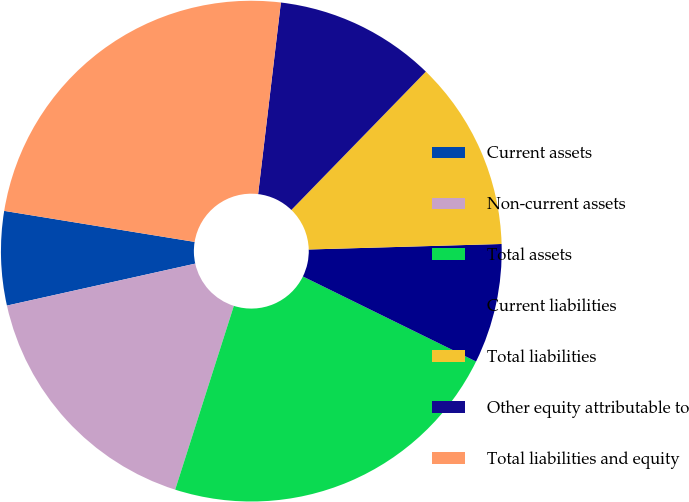Convert chart. <chart><loc_0><loc_0><loc_500><loc_500><pie_chart><fcel>Current assets<fcel>Non-current assets<fcel>Total assets<fcel>Current liabilities<fcel>Total liabilities<fcel>Other equity attributable to<fcel>Total liabilities and equity<nl><fcel>6.06%<fcel>16.59%<fcel>22.65%<fcel>7.72%<fcel>12.27%<fcel>10.39%<fcel>24.31%<nl></chart> 